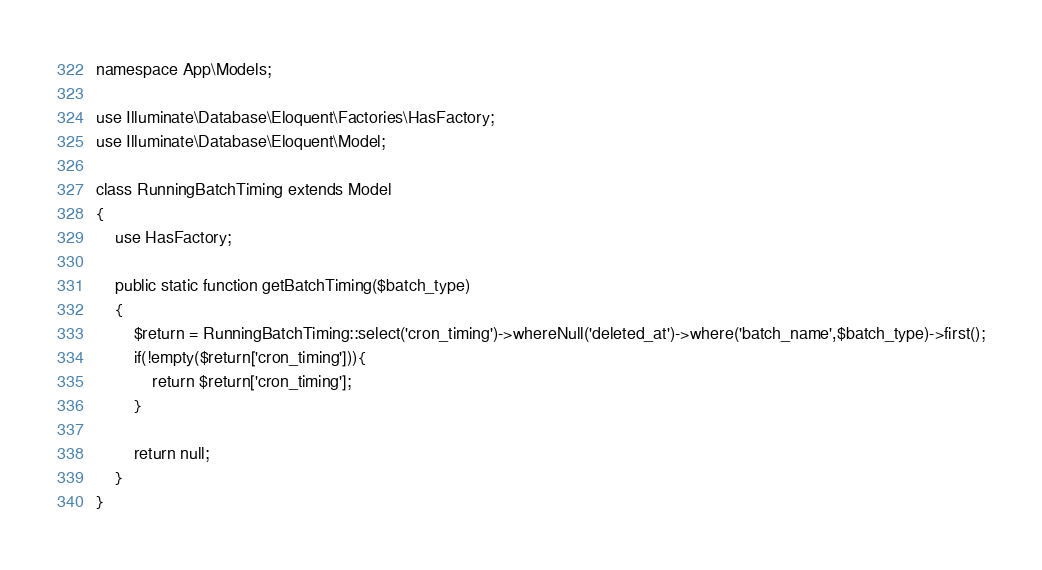Convert code to text. <code><loc_0><loc_0><loc_500><loc_500><_PHP_>
namespace App\Models;

use Illuminate\Database\Eloquent\Factories\HasFactory;
use Illuminate\Database\Eloquent\Model;

class RunningBatchTiming extends Model
{
    use HasFactory;

    public static function getBatchTiming($batch_type)
    {
        $return = RunningBatchTiming::select('cron_timing')->whereNull('deleted_at')->where('batch_name',$batch_type)->first();
        if(!empty($return['cron_timing'])){
            return $return['cron_timing'];
        }

        return null;
    }
}
</code> 